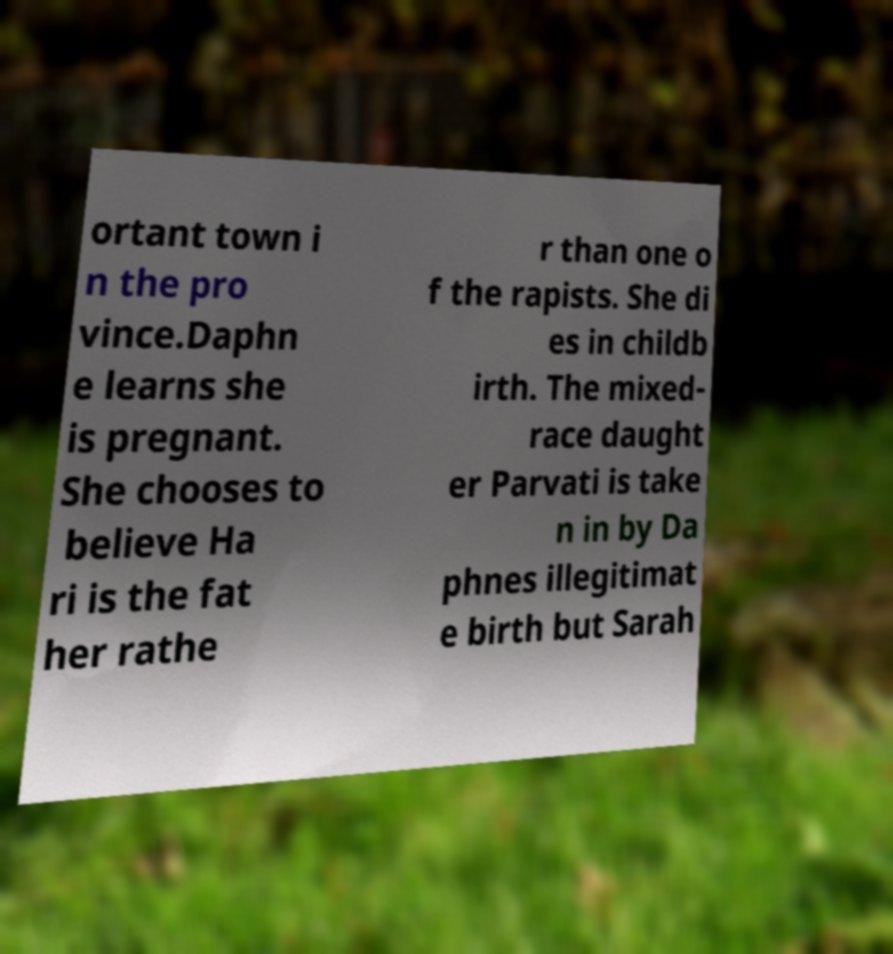Could you assist in decoding the text presented in this image and type it out clearly? ortant town i n the pro vince.Daphn e learns she is pregnant. She chooses to believe Ha ri is the fat her rathe r than one o f the rapists. She di es in childb irth. The mixed- race daught er Parvati is take n in by Da phnes illegitimat e birth but Sarah 